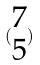Convert formula to latex. <formula><loc_0><loc_0><loc_500><loc_500>( \begin{matrix} 7 \\ 5 \end{matrix} )</formula> 